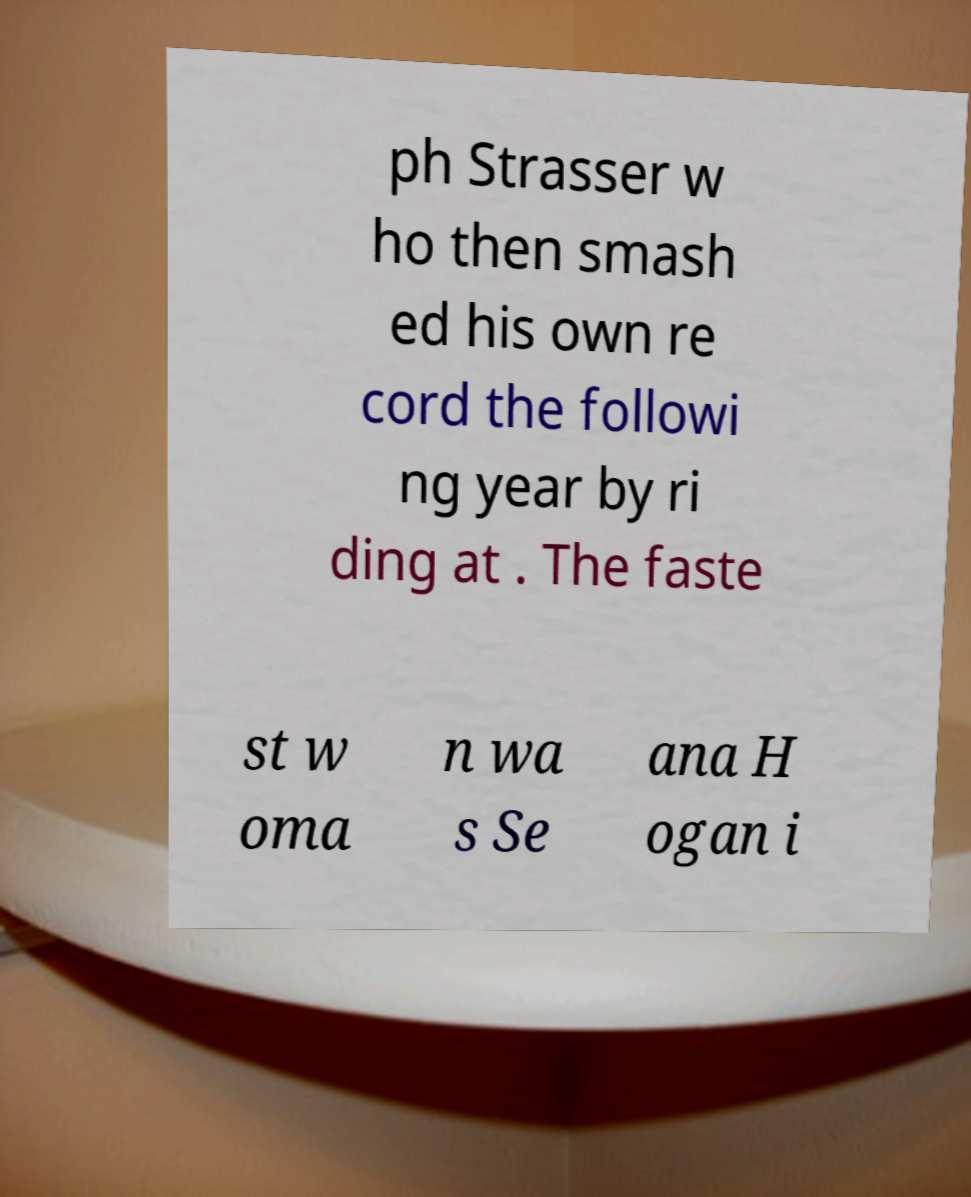What messages or text are displayed in this image? I need them in a readable, typed format. ph Strasser w ho then smash ed his own re cord the followi ng year by ri ding at . The faste st w oma n wa s Se ana H ogan i 